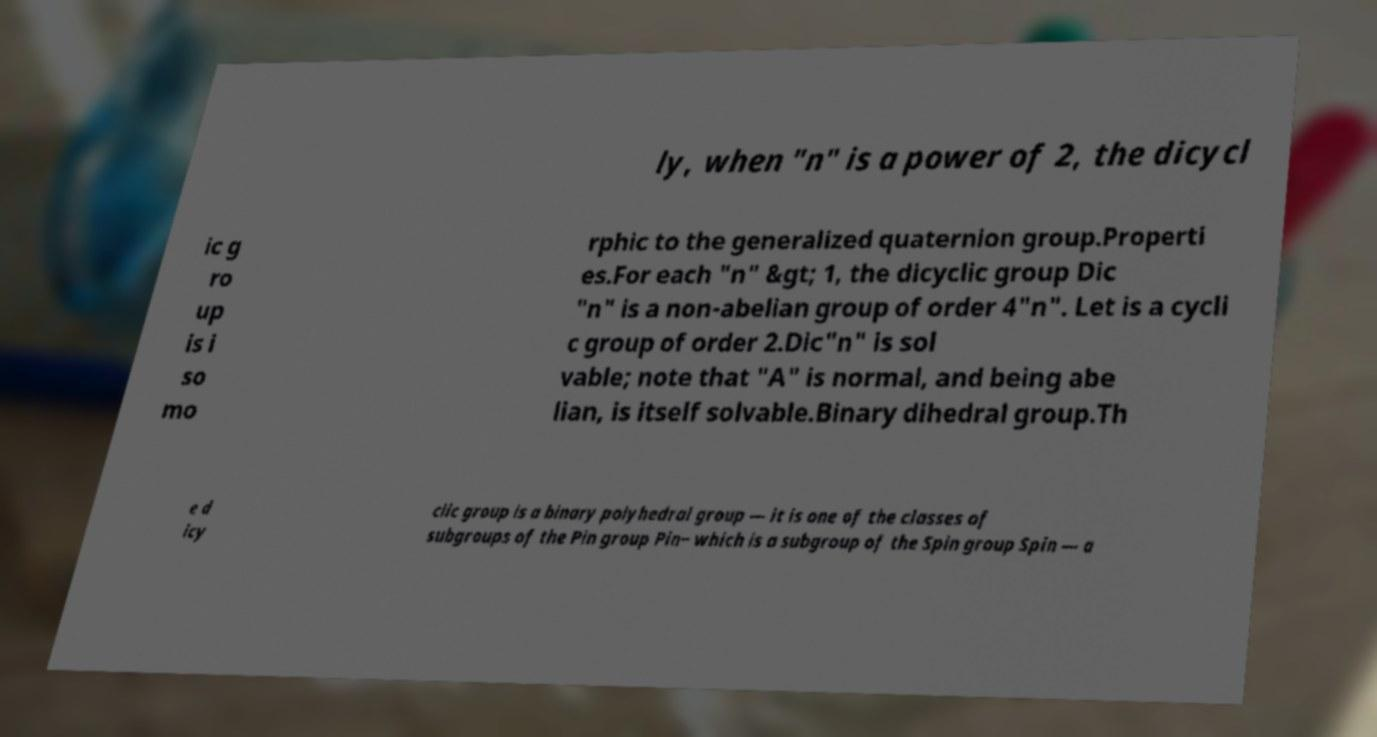What messages or text are displayed in this image? I need them in a readable, typed format. ly, when "n" is a power of 2, the dicycl ic g ro up is i so mo rphic to the generalized quaternion group.Properti es.For each "n" &gt; 1, the dicyclic group Dic "n" is a non-abelian group of order 4"n". Let is a cycli c group of order 2.Dic"n" is sol vable; note that "A" is normal, and being abe lian, is itself solvable.Binary dihedral group.Th e d icy clic group is a binary polyhedral group — it is one of the classes of subgroups of the Pin group Pin− which is a subgroup of the Spin group Spin — a 